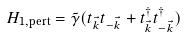Convert formula to latex. <formula><loc_0><loc_0><loc_500><loc_500>H _ { 1 , \text {pert} } = \tilde { \gamma } ( t _ { \vec { k } } t _ { - \vec { k } } + t ^ { \dagger } _ { \vec { k } } t ^ { \dagger } _ { - \vec { k } } )</formula> 